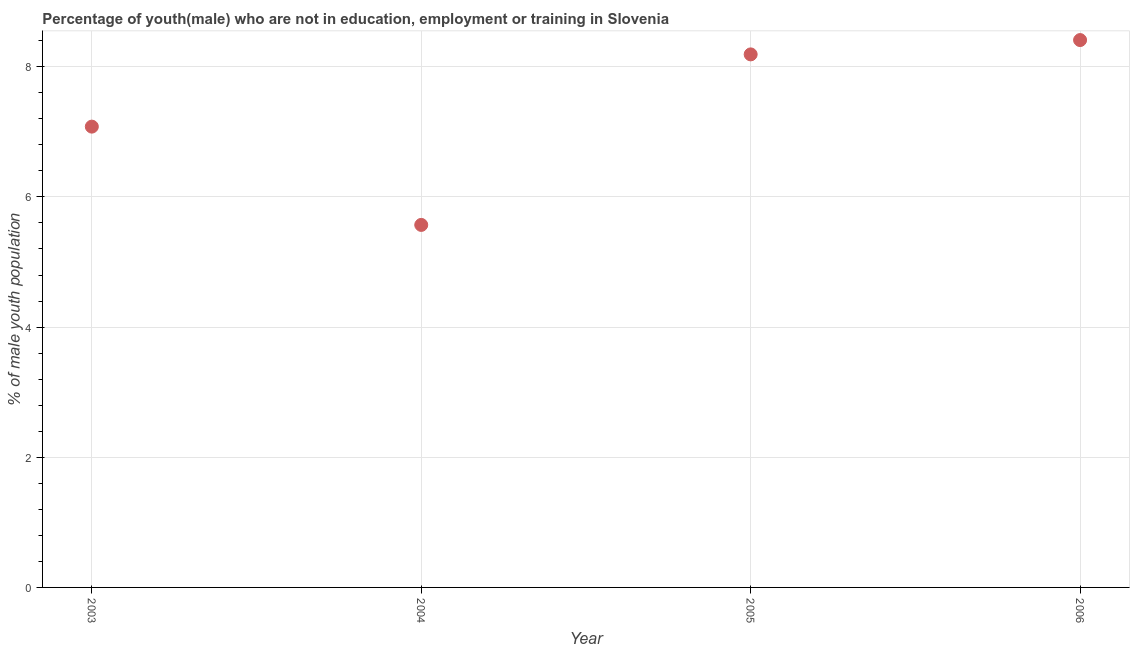What is the unemployed male youth population in 2006?
Offer a terse response. 8.41. Across all years, what is the maximum unemployed male youth population?
Keep it short and to the point. 8.41. Across all years, what is the minimum unemployed male youth population?
Provide a short and direct response. 5.57. In which year was the unemployed male youth population minimum?
Offer a terse response. 2004. What is the sum of the unemployed male youth population?
Provide a short and direct response. 29.25. What is the difference between the unemployed male youth population in 2005 and 2006?
Make the answer very short. -0.22. What is the average unemployed male youth population per year?
Provide a succinct answer. 7.31. What is the median unemployed male youth population?
Your response must be concise. 7.63. What is the ratio of the unemployed male youth population in 2005 to that in 2006?
Your answer should be compact. 0.97. Is the unemployed male youth population in 2003 less than that in 2005?
Give a very brief answer. Yes. What is the difference between the highest and the second highest unemployed male youth population?
Offer a very short reply. 0.22. Is the sum of the unemployed male youth population in 2003 and 2005 greater than the maximum unemployed male youth population across all years?
Make the answer very short. Yes. What is the difference between the highest and the lowest unemployed male youth population?
Your answer should be very brief. 2.84. In how many years, is the unemployed male youth population greater than the average unemployed male youth population taken over all years?
Keep it short and to the point. 2. How many dotlines are there?
Your answer should be very brief. 1. How many years are there in the graph?
Offer a very short reply. 4. What is the difference between two consecutive major ticks on the Y-axis?
Provide a succinct answer. 2. What is the title of the graph?
Your answer should be very brief. Percentage of youth(male) who are not in education, employment or training in Slovenia. What is the label or title of the X-axis?
Your response must be concise. Year. What is the label or title of the Y-axis?
Provide a short and direct response. % of male youth population. What is the % of male youth population in 2003?
Offer a very short reply. 7.08. What is the % of male youth population in 2004?
Offer a very short reply. 5.57. What is the % of male youth population in 2005?
Offer a very short reply. 8.19. What is the % of male youth population in 2006?
Your answer should be compact. 8.41. What is the difference between the % of male youth population in 2003 and 2004?
Keep it short and to the point. 1.51. What is the difference between the % of male youth population in 2003 and 2005?
Make the answer very short. -1.11. What is the difference between the % of male youth population in 2003 and 2006?
Keep it short and to the point. -1.33. What is the difference between the % of male youth population in 2004 and 2005?
Keep it short and to the point. -2.62. What is the difference between the % of male youth population in 2004 and 2006?
Ensure brevity in your answer.  -2.84. What is the difference between the % of male youth population in 2005 and 2006?
Offer a terse response. -0.22. What is the ratio of the % of male youth population in 2003 to that in 2004?
Ensure brevity in your answer.  1.27. What is the ratio of the % of male youth population in 2003 to that in 2005?
Your response must be concise. 0.86. What is the ratio of the % of male youth population in 2003 to that in 2006?
Your answer should be very brief. 0.84. What is the ratio of the % of male youth population in 2004 to that in 2005?
Your answer should be compact. 0.68. What is the ratio of the % of male youth population in 2004 to that in 2006?
Keep it short and to the point. 0.66. 